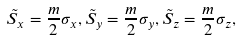Convert formula to latex. <formula><loc_0><loc_0><loc_500><loc_500>\tilde { S } _ { x } = \frac { m } { 2 } \sigma _ { x } , \tilde { S } _ { y } = \frac { m } { 2 } \sigma _ { y } , \tilde { S } _ { z } = \frac { m } { 2 } \sigma _ { z } ,</formula> 